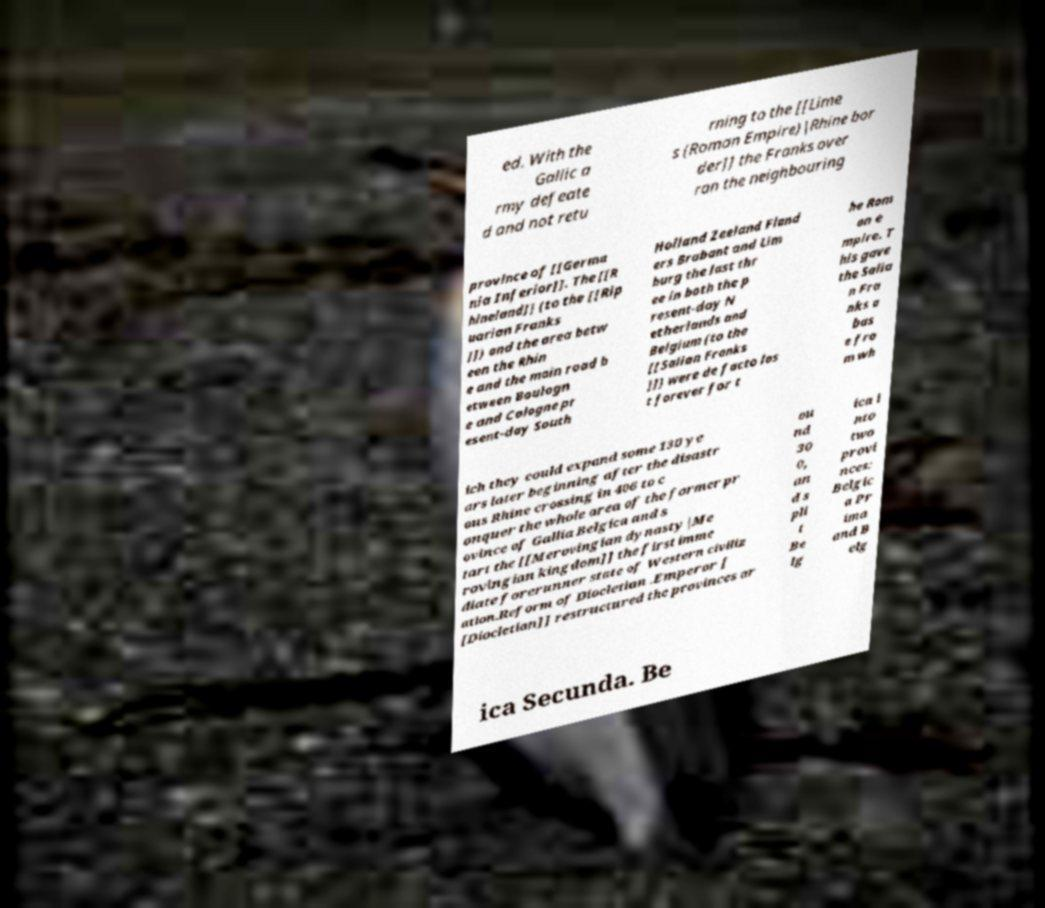There's text embedded in this image that I need extracted. Can you transcribe it verbatim? ed. With the Gallic a rmy defeate d and not retu rning to the [[Lime s (Roman Empire)|Rhine bor der]] the Franks over ran the neighbouring province of [[Germa nia Inferior]]. The [[R hineland]] (to the [[Rip uarian Franks ]]) and the area betw een the Rhin e and the main road b etween Boulogn e and Cologne pr esent-day South Holland Zeeland Fland ers Brabant and Lim burg the last thr ee in both the p resent-day N etherlands and Belgium (to the [[Salian Franks ]]) were de facto los t forever for t he Rom an e mpire. T his gave the Salia n Fra nks a bas e fro m wh ich they could expand some 130 ye ars later beginning after the disastr ous Rhine crossing in 406 to c onquer the whole area of the former pr ovince of Gallia Belgica and s tart the [[Merovingian dynasty|Me rovingian kingdom]] the first imme diate forerunner state of Western civiliz ation.Reform of Diocletian .Emperor [ [Diocletian]] restructured the provinces ar ou nd 30 0, an d s pli t Be lg ica i nto two provi nces: Belgic a Pr ima and B elg ica Secunda. Be 